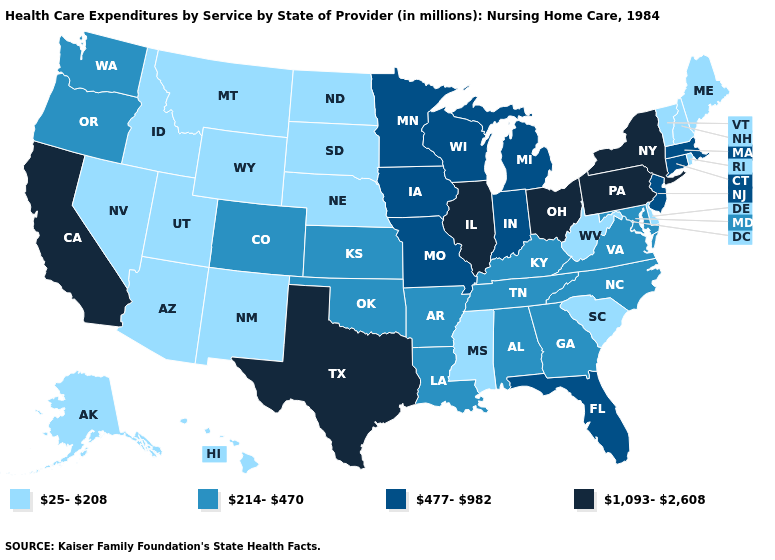What is the lowest value in the USA?
Answer briefly. 25-208. What is the value of Missouri?
Quick response, please. 477-982. What is the value of Idaho?
Give a very brief answer. 25-208. What is the highest value in the Northeast ?
Concise answer only. 1,093-2,608. What is the value of Michigan?
Give a very brief answer. 477-982. Which states have the lowest value in the USA?
Short answer required. Alaska, Arizona, Delaware, Hawaii, Idaho, Maine, Mississippi, Montana, Nebraska, Nevada, New Hampshire, New Mexico, North Dakota, Rhode Island, South Carolina, South Dakota, Utah, Vermont, West Virginia, Wyoming. What is the value of Missouri?
Write a very short answer. 477-982. Which states have the lowest value in the MidWest?
Write a very short answer. Nebraska, North Dakota, South Dakota. Does the first symbol in the legend represent the smallest category?
Write a very short answer. Yes. Name the states that have a value in the range 1,093-2,608?
Be succinct. California, Illinois, New York, Ohio, Pennsylvania, Texas. What is the value of Arizona?
Concise answer only. 25-208. What is the value of Colorado?
Keep it brief. 214-470. Which states have the lowest value in the USA?
Answer briefly. Alaska, Arizona, Delaware, Hawaii, Idaho, Maine, Mississippi, Montana, Nebraska, Nevada, New Hampshire, New Mexico, North Dakota, Rhode Island, South Carolina, South Dakota, Utah, Vermont, West Virginia, Wyoming. What is the lowest value in the West?
Concise answer only. 25-208. Does Arkansas have the lowest value in the USA?
Short answer required. No. 